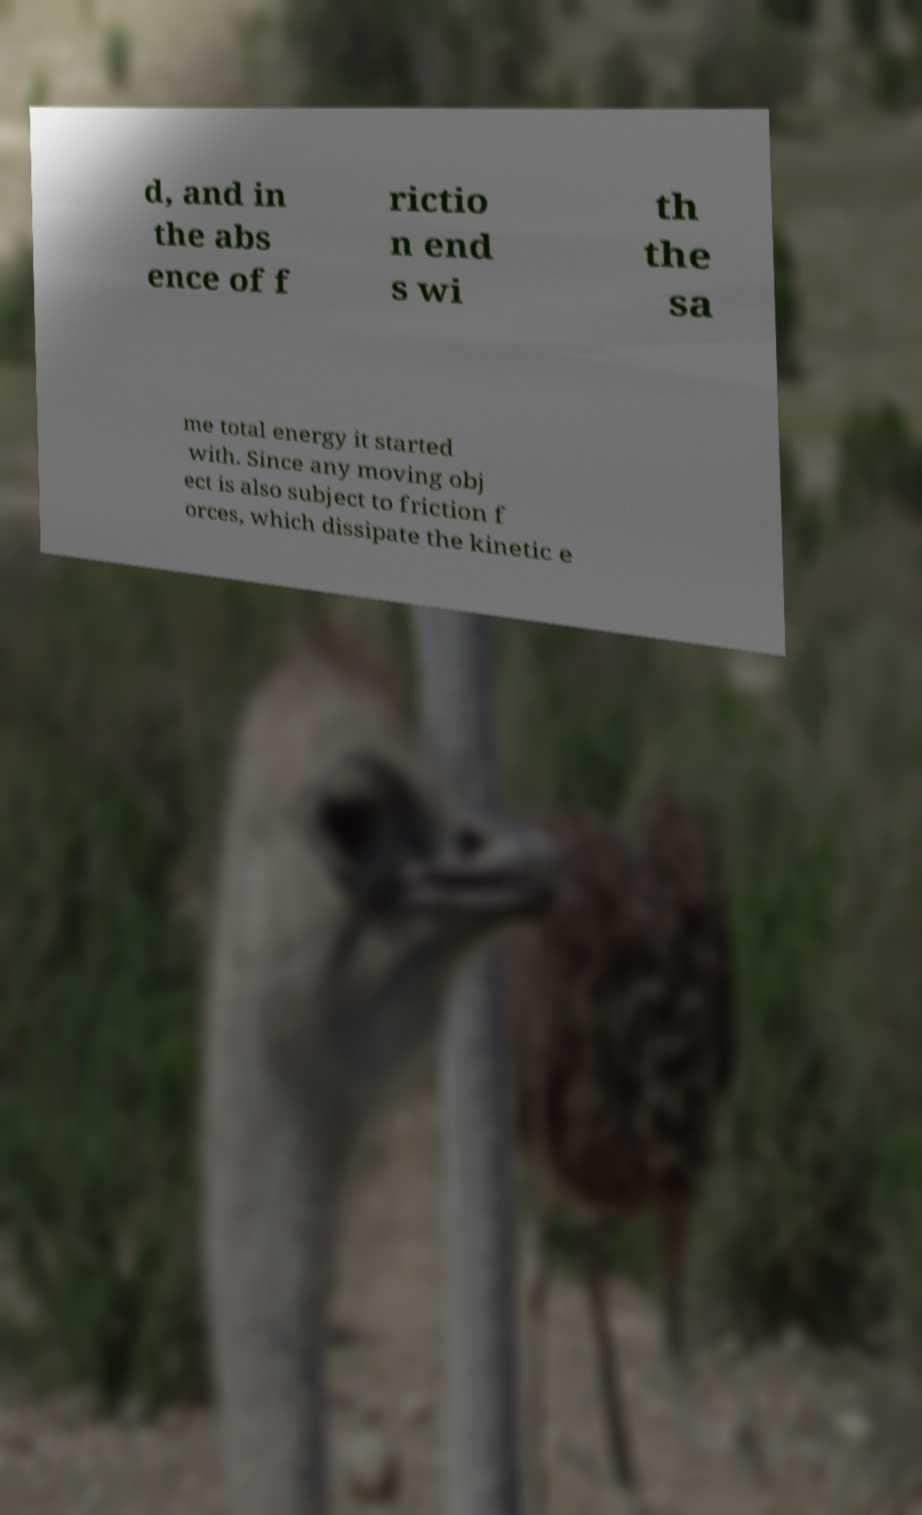Please identify and transcribe the text found in this image. d, and in the abs ence of f rictio n end s wi th the sa me total energy it started with. Since any moving obj ect is also subject to friction f orces, which dissipate the kinetic e 